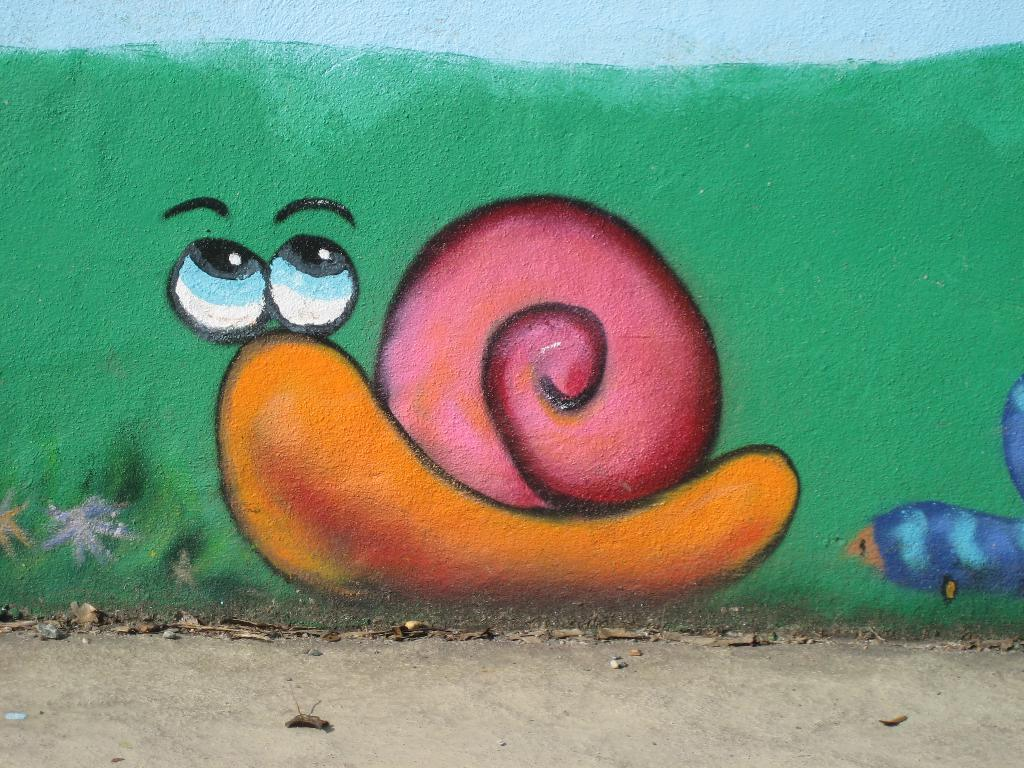What is depicted in the painting that is visible in the image? There is a painting of a snail in the image. Where is the painting located in the image? The painting is on a wall. What type of calculator is used by the snail in the painting? There is no calculator present in the painting or the image; it features a snail. 